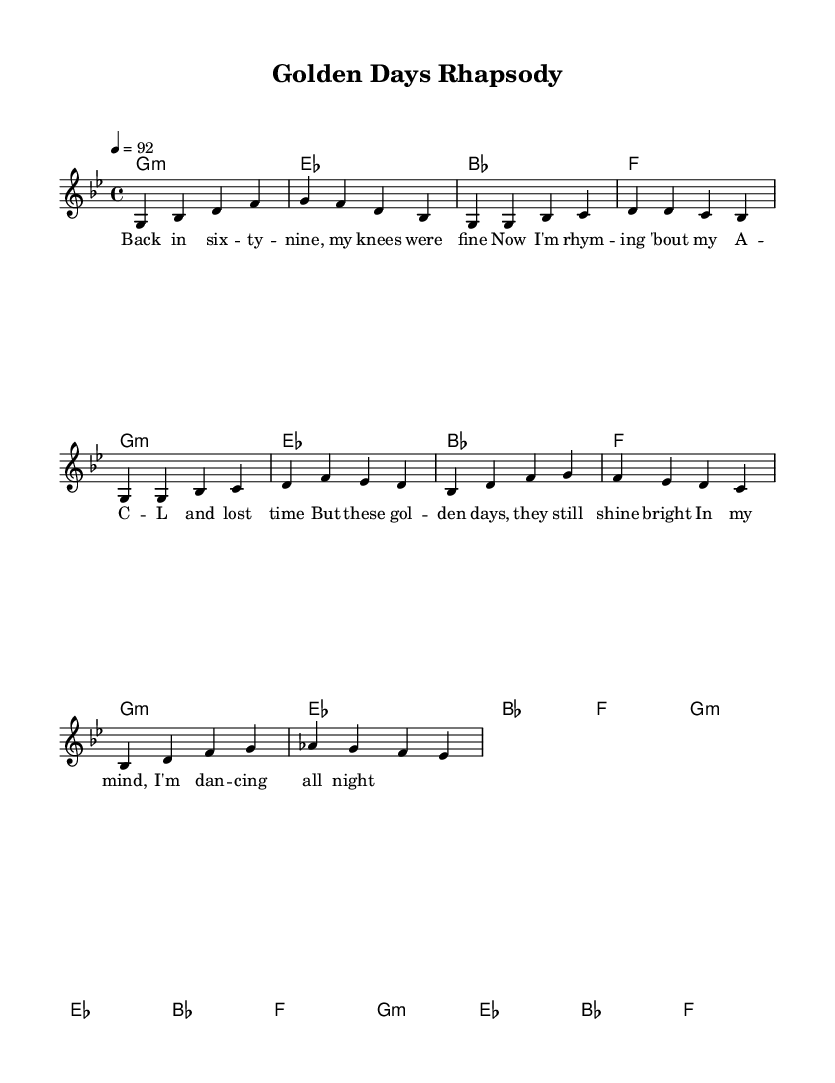What is the key signature of this music? The key signature indicated in the global section of the code is G minor, which consists of two flats.
Answer: G minor What is the time signature of this piece? The time signature is specified as 4/4 in the global section, meaning there are four beats in each measure and a quarter note gets one beat.
Answer: 4/4 What is the tempo marking for this music? The tempo is indicated as 92 beats per minute, which is a moderate pace for the music.
Answer: 92 How many measures are in the chorus section? The chorus is composed of four measures as indicated under the Chorus section in the melody.
Answer: 4 What is the first note played in the introduction? The first note listed in the melody's introduction is G, which is played as the opening note in the eighth measure.
Answer: G What musical style is represented in this sheet music? The music is identified as Nostalgic rap, which blends modern beats with samples from earlier decades, showcasing lyrics and a rhythm typical of rap music.
Answer: Nostalgic rap What lyrical theme is presented in the snippet? The lyrics reflect nostalgia for the past, focusing on reminiscence about the artist's ACL surgery and the joy of dancing in their memories.
Answer: Nostalgia 